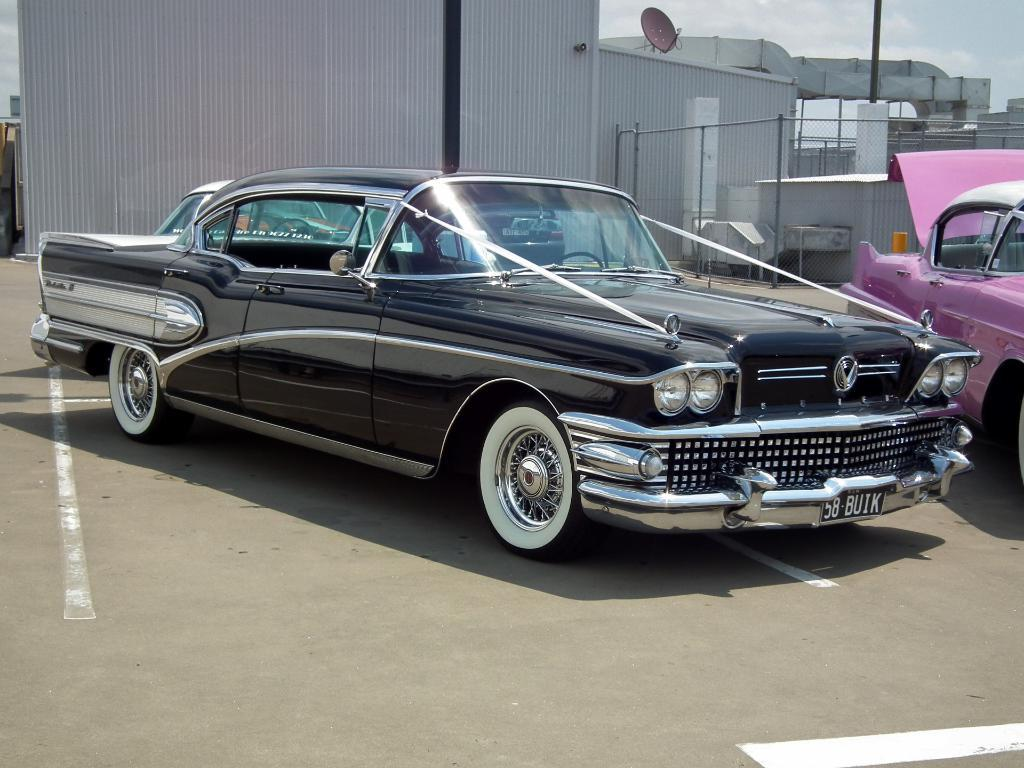How many cars are visible in the foreground of the image? There are three cars in the foreground of the image. Where are the cars located? The cars are on the road. What can be seen in the background of the image? There is a shelter, an antenna dish, a pole, fencing, and the sky visible in the background of the image. What is the weather like in the image? The presence of clouds in the sky suggests that it might be partly cloudy. Can you see the queen in the image? There is no queen present in the image. 